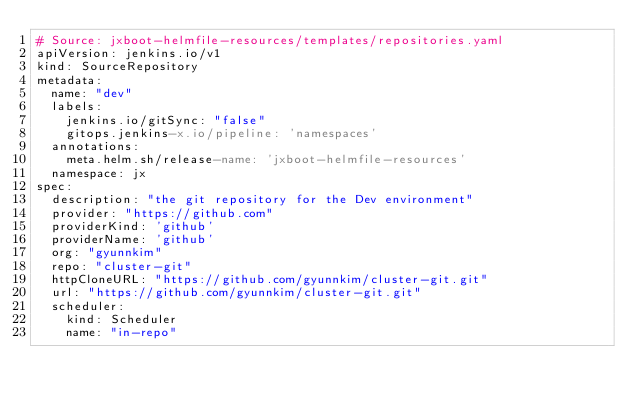Convert code to text. <code><loc_0><loc_0><loc_500><loc_500><_YAML_># Source: jxboot-helmfile-resources/templates/repositories.yaml
apiVersion: jenkins.io/v1
kind: SourceRepository
metadata:
  name: "dev"
  labels:
    jenkins.io/gitSync: "false"
    gitops.jenkins-x.io/pipeline: 'namespaces'
  annotations:
    meta.helm.sh/release-name: 'jxboot-helmfile-resources'
  namespace: jx
spec:
  description: "the git repository for the Dev environment"
  provider: "https://github.com"
  providerKind: 'github'
  providerName: 'github'
  org: "gyunnkim"
  repo: "cluster-git"
  httpCloneURL: "https://github.com/gyunnkim/cluster-git.git"
  url: "https://github.com/gyunnkim/cluster-git.git"
  scheduler:
    kind: Scheduler
    name: "in-repo"
</code> 